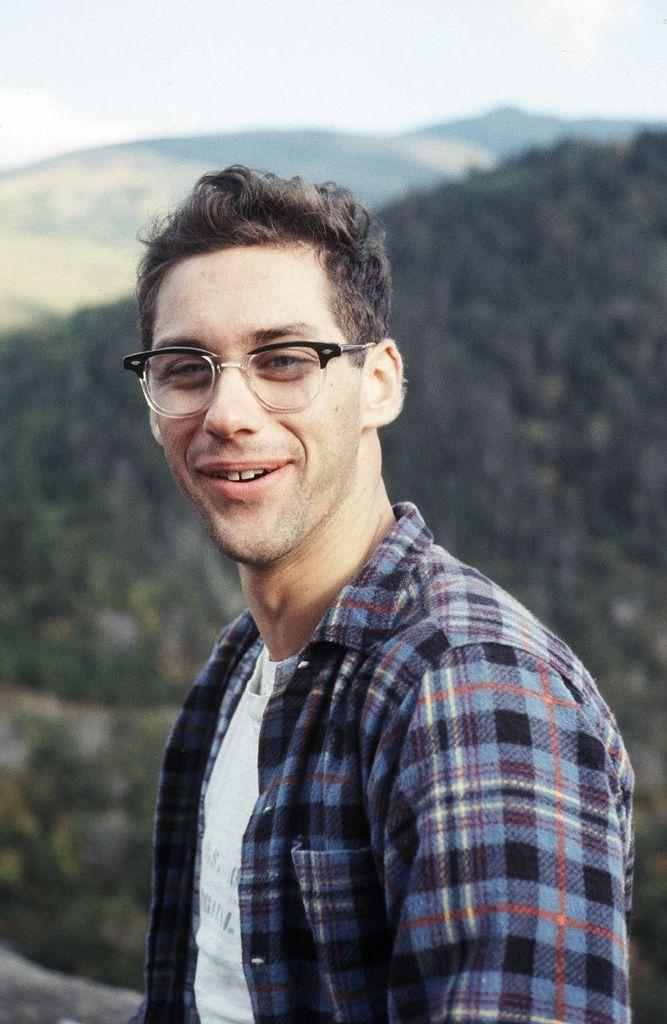What is the person in the image wearing on their face? The person in the image is wearing eyeglasses. What type of landscape can be seen in the image? There are hills visible in the image. What is visible at the top of the image? The sky is visible at the top of the image. What type of sock is the person wearing in the image? There is no sock visible in the image; the person is wearing eyeglasses. What type of fiction is being read by the person in the image? There is no book or any indication of reading in the image; the person is wearing eyeglasses. 